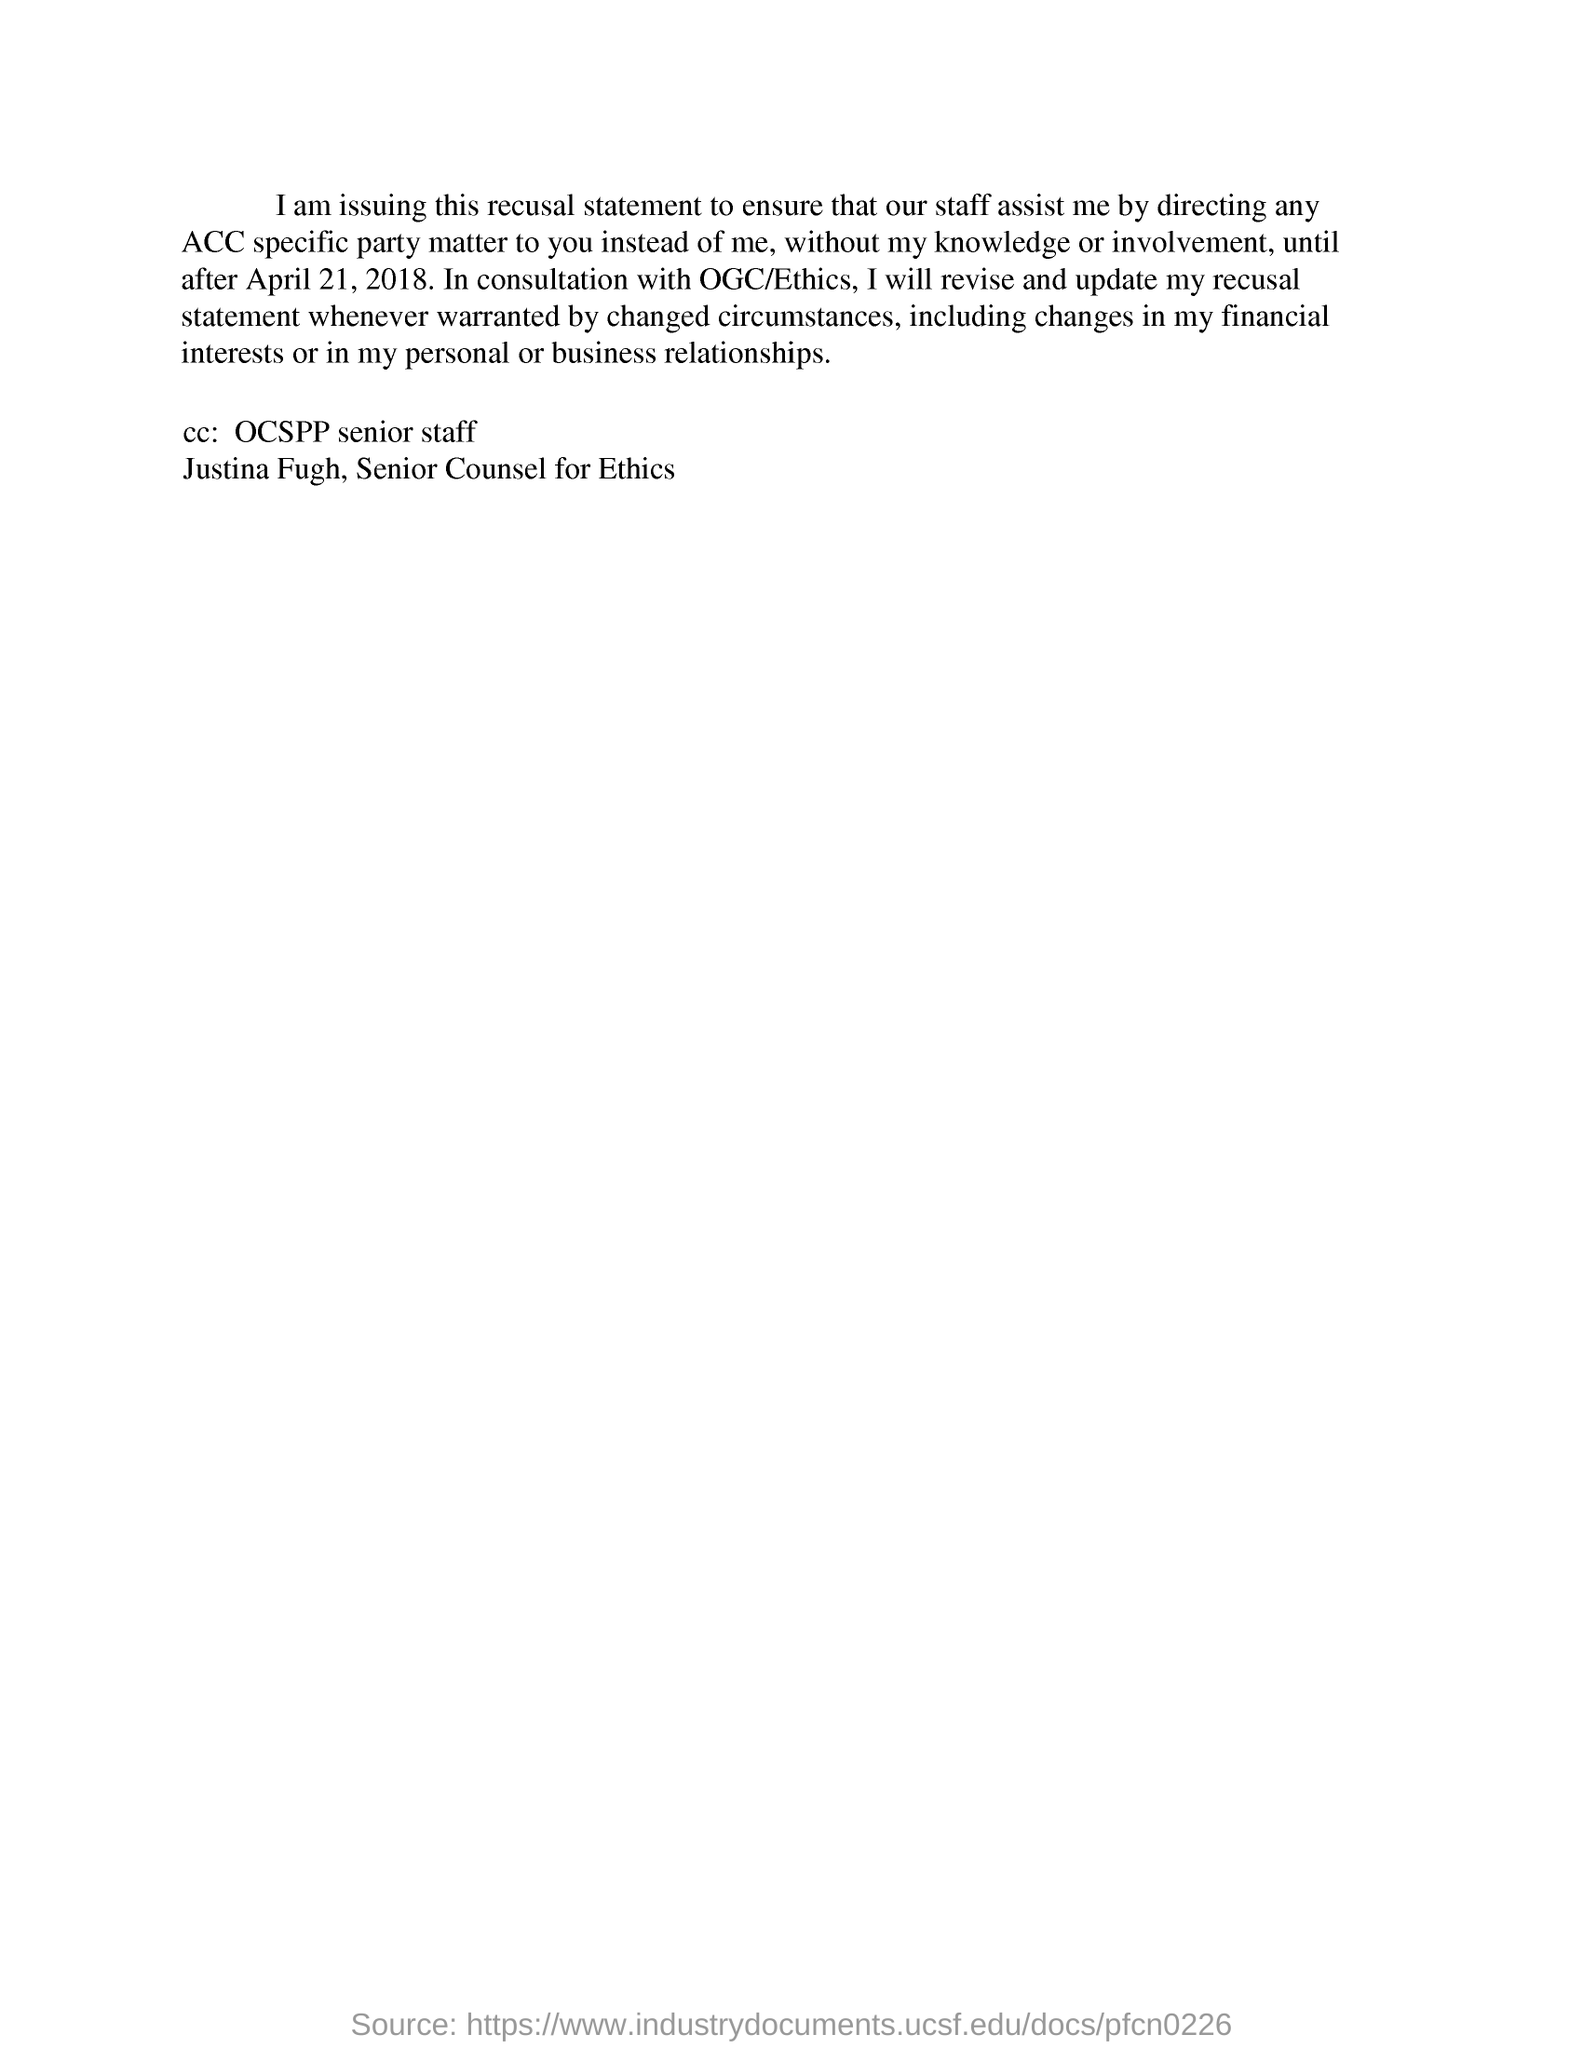Who is mentioned in the CC:?
Provide a succinct answer. OCSPP senior staff Justina Fugh, Senior Counsel for Ethics. 